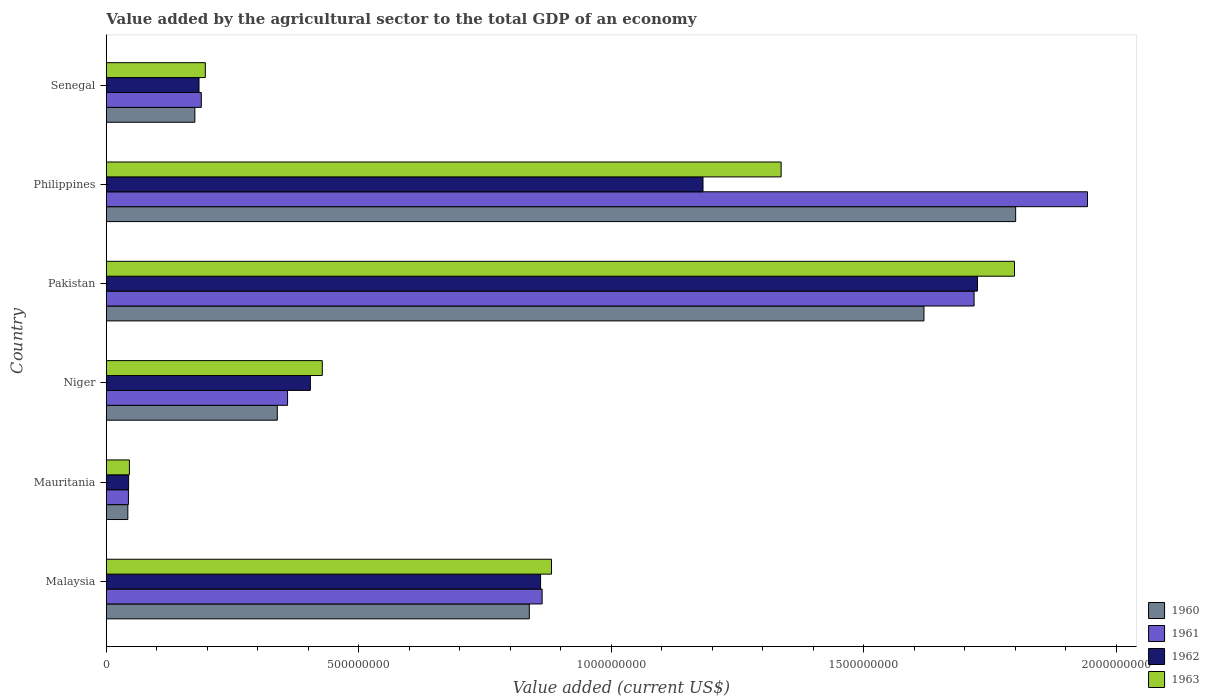How many groups of bars are there?
Keep it short and to the point. 6. Are the number of bars per tick equal to the number of legend labels?
Provide a succinct answer. Yes. How many bars are there on the 1st tick from the top?
Your answer should be very brief. 4. What is the label of the 4th group of bars from the top?
Keep it short and to the point. Niger. What is the value added by the agricultural sector to the total GDP in 1961 in Malaysia?
Provide a succinct answer. 8.63e+08. Across all countries, what is the maximum value added by the agricultural sector to the total GDP in 1962?
Provide a short and direct response. 1.73e+09. Across all countries, what is the minimum value added by the agricultural sector to the total GDP in 1960?
Give a very brief answer. 4.26e+07. In which country was the value added by the agricultural sector to the total GDP in 1963 maximum?
Ensure brevity in your answer.  Pakistan. In which country was the value added by the agricultural sector to the total GDP in 1961 minimum?
Your response must be concise. Mauritania. What is the total value added by the agricultural sector to the total GDP in 1961 in the graph?
Make the answer very short. 5.12e+09. What is the difference between the value added by the agricultural sector to the total GDP in 1960 in Pakistan and that in Senegal?
Keep it short and to the point. 1.44e+09. What is the difference between the value added by the agricultural sector to the total GDP in 1961 in Niger and the value added by the agricultural sector to the total GDP in 1962 in Philippines?
Provide a short and direct response. -8.23e+08. What is the average value added by the agricultural sector to the total GDP in 1963 per country?
Offer a very short reply. 7.81e+08. What is the difference between the value added by the agricultural sector to the total GDP in 1960 and value added by the agricultural sector to the total GDP in 1963 in Philippines?
Provide a short and direct response. 4.64e+08. What is the ratio of the value added by the agricultural sector to the total GDP in 1960 in Philippines to that in Senegal?
Give a very brief answer. 10.27. Is the value added by the agricultural sector to the total GDP in 1961 in Malaysia less than that in Senegal?
Your response must be concise. No. Is the difference between the value added by the agricultural sector to the total GDP in 1960 in Malaysia and Senegal greater than the difference between the value added by the agricultural sector to the total GDP in 1963 in Malaysia and Senegal?
Give a very brief answer. No. What is the difference between the highest and the second highest value added by the agricultural sector to the total GDP in 1960?
Your answer should be compact. 1.82e+08. What is the difference between the highest and the lowest value added by the agricultural sector to the total GDP in 1961?
Your answer should be compact. 1.90e+09. In how many countries, is the value added by the agricultural sector to the total GDP in 1961 greater than the average value added by the agricultural sector to the total GDP in 1961 taken over all countries?
Your answer should be very brief. 3. Is the sum of the value added by the agricultural sector to the total GDP in 1962 in Pakistan and Senegal greater than the maximum value added by the agricultural sector to the total GDP in 1963 across all countries?
Make the answer very short. Yes. Is it the case that in every country, the sum of the value added by the agricultural sector to the total GDP in 1962 and value added by the agricultural sector to the total GDP in 1961 is greater than the sum of value added by the agricultural sector to the total GDP in 1963 and value added by the agricultural sector to the total GDP in 1960?
Make the answer very short. No. What does the 1st bar from the top in Malaysia represents?
Give a very brief answer. 1963. What does the 1st bar from the bottom in Niger represents?
Ensure brevity in your answer.  1960. Are all the bars in the graph horizontal?
Offer a terse response. Yes. Are the values on the major ticks of X-axis written in scientific E-notation?
Ensure brevity in your answer.  No. What is the title of the graph?
Provide a succinct answer. Value added by the agricultural sector to the total GDP of an economy. Does "1989" appear as one of the legend labels in the graph?
Provide a short and direct response. No. What is the label or title of the X-axis?
Your answer should be compact. Value added (current US$). What is the label or title of the Y-axis?
Provide a short and direct response. Country. What is the Value added (current US$) in 1960 in Malaysia?
Provide a succinct answer. 8.38e+08. What is the Value added (current US$) in 1961 in Malaysia?
Keep it short and to the point. 8.63e+08. What is the Value added (current US$) of 1962 in Malaysia?
Offer a terse response. 8.60e+08. What is the Value added (current US$) of 1963 in Malaysia?
Your answer should be very brief. 8.82e+08. What is the Value added (current US$) of 1960 in Mauritania?
Your answer should be compact. 4.26e+07. What is the Value added (current US$) of 1961 in Mauritania?
Offer a terse response. 4.37e+07. What is the Value added (current US$) of 1962 in Mauritania?
Your answer should be very brief. 4.41e+07. What is the Value added (current US$) in 1963 in Mauritania?
Your answer should be compact. 4.57e+07. What is the Value added (current US$) of 1960 in Niger?
Offer a terse response. 3.39e+08. What is the Value added (current US$) in 1961 in Niger?
Offer a very short reply. 3.59e+08. What is the Value added (current US$) of 1962 in Niger?
Make the answer very short. 4.04e+08. What is the Value added (current US$) in 1963 in Niger?
Your answer should be very brief. 4.28e+08. What is the Value added (current US$) of 1960 in Pakistan?
Ensure brevity in your answer.  1.62e+09. What is the Value added (current US$) of 1961 in Pakistan?
Offer a terse response. 1.72e+09. What is the Value added (current US$) in 1962 in Pakistan?
Ensure brevity in your answer.  1.73e+09. What is the Value added (current US$) in 1963 in Pakistan?
Ensure brevity in your answer.  1.80e+09. What is the Value added (current US$) in 1960 in Philippines?
Provide a short and direct response. 1.80e+09. What is the Value added (current US$) in 1961 in Philippines?
Keep it short and to the point. 1.94e+09. What is the Value added (current US$) in 1962 in Philippines?
Ensure brevity in your answer.  1.18e+09. What is the Value added (current US$) of 1963 in Philippines?
Keep it short and to the point. 1.34e+09. What is the Value added (current US$) of 1960 in Senegal?
Your answer should be compact. 1.75e+08. What is the Value added (current US$) of 1961 in Senegal?
Provide a succinct answer. 1.88e+08. What is the Value added (current US$) of 1962 in Senegal?
Provide a short and direct response. 1.84e+08. What is the Value added (current US$) in 1963 in Senegal?
Your answer should be very brief. 1.96e+08. Across all countries, what is the maximum Value added (current US$) in 1960?
Provide a succinct answer. 1.80e+09. Across all countries, what is the maximum Value added (current US$) in 1961?
Offer a terse response. 1.94e+09. Across all countries, what is the maximum Value added (current US$) in 1962?
Provide a short and direct response. 1.73e+09. Across all countries, what is the maximum Value added (current US$) of 1963?
Ensure brevity in your answer.  1.80e+09. Across all countries, what is the minimum Value added (current US$) of 1960?
Your answer should be very brief. 4.26e+07. Across all countries, what is the minimum Value added (current US$) in 1961?
Offer a terse response. 4.37e+07. Across all countries, what is the minimum Value added (current US$) in 1962?
Make the answer very short. 4.41e+07. Across all countries, what is the minimum Value added (current US$) of 1963?
Offer a very short reply. 4.57e+07. What is the total Value added (current US$) in 1960 in the graph?
Your response must be concise. 4.81e+09. What is the total Value added (current US$) in 1961 in the graph?
Your answer should be very brief. 5.12e+09. What is the total Value added (current US$) in 1962 in the graph?
Your answer should be compact. 4.40e+09. What is the total Value added (current US$) in 1963 in the graph?
Offer a terse response. 4.69e+09. What is the difference between the Value added (current US$) of 1960 in Malaysia and that in Mauritania?
Make the answer very short. 7.95e+08. What is the difference between the Value added (current US$) in 1961 in Malaysia and that in Mauritania?
Make the answer very short. 8.19e+08. What is the difference between the Value added (current US$) of 1962 in Malaysia and that in Mauritania?
Make the answer very short. 8.16e+08. What is the difference between the Value added (current US$) in 1963 in Malaysia and that in Mauritania?
Offer a terse response. 8.36e+08. What is the difference between the Value added (current US$) in 1960 in Malaysia and that in Niger?
Offer a terse response. 4.99e+08. What is the difference between the Value added (current US$) in 1961 in Malaysia and that in Niger?
Give a very brief answer. 5.04e+08. What is the difference between the Value added (current US$) in 1962 in Malaysia and that in Niger?
Give a very brief answer. 4.56e+08. What is the difference between the Value added (current US$) of 1963 in Malaysia and that in Niger?
Your answer should be very brief. 4.54e+08. What is the difference between the Value added (current US$) of 1960 in Malaysia and that in Pakistan?
Your response must be concise. -7.82e+08. What is the difference between the Value added (current US$) in 1961 in Malaysia and that in Pakistan?
Offer a very short reply. -8.56e+08. What is the difference between the Value added (current US$) in 1962 in Malaysia and that in Pakistan?
Your response must be concise. -8.65e+08. What is the difference between the Value added (current US$) in 1963 in Malaysia and that in Pakistan?
Offer a terse response. -9.17e+08. What is the difference between the Value added (current US$) of 1960 in Malaysia and that in Philippines?
Keep it short and to the point. -9.63e+08. What is the difference between the Value added (current US$) in 1961 in Malaysia and that in Philippines?
Your response must be concise. -1.08e+09. What is the difference between the Value added (current US$) of 1962 in Malaysia and that in Philippines?
Your response must be concise. -3.22e+08. What is the difference between the Value added (current US$) in 1963 in Malaysia and that in Philippines?
Your answer should be very brief. -4.55e+08. What is the difference between the Value added (current US$) in 1960 in Malaysia and that in Senegal?
Your response must be concise. 6.62e+08. What is the difference between the Value added (current US$) in 1961 in Malaysia and that in Senegal?
Offer a terse response. 6.75e+08. What is the difference between the Value added (current US$) of 1962 in Malaysia and that in Senegal?
Offer a very short reply. 6.76e+08. What is the difference between the Value added (current US$) of 1963 in Malaysia and that in Senegal?
Your answer should be compact. 6.86e+08. What is the difference between the Value added (current US$) in 1960 in Mauritania and that in Niger?
Provide a succinct answer. -2.96e+08. What is the difference between the Value added (current US$) of 1961 in Mauritania and that in Niger?
Provide a succinct answer. -3.15e+08. What is the difference between the Value added (current US$) in 1962 in Mauritania and that in Niger?
Offer a terse response. -3.60e+08. What is the difference between the Value added (current US$) in 1963 in Mauritania and that in Niger?
Ensure brevity in your answer.  -3.82e+08. What is the difference between the Value added (current US$) of 1960 in Mauritania and that in Pakistan?
Ensure brevity in your answer.  -1.58e+09. What is the difference between the Value added (current US$) of 1961 in Mauritania and that in Pakistan?
Your response must be concise. -1.67e+09. What is the difference between the Value added (current US$) of 1962 in Mauritania and that in Pakistan?
Give a very brief answer. -1.68e+09. What is the difference between the Value added (current US$) in 1963 in Mauritania and that in Pakistan?
Your response must be concise. -1.75e+09. What is the difference between the Value added (current US$) of 1960 in Mauritania and that in Philippines?
Your answer should be very brief. -1.76e+09. What is the difference between the Value added (current US$) of 1961 in Mauritania and that in Philippines?
Ensure brevity in your answer.  -1.90e+09. What is the difference between the Value added (current US$) in 1962 in Mauritania and that in Philippines?
Keep it short and to the point. -1.14e+09. What is the difference between the Value added (current US$) in 1963 in Mauritania and that in Philippines?
Offer a very short reply. -1.29e+09. What is the difference between the Value added (current US$) of 1960 in Mauritania and that in Senegal?
Provide a succinct answer. -1.33e+08. What is the difference between the Value added (current US$) in 1961 in Mauritania and that in Senegal?
Offer a terse response. -1.44e+08. What is the difference between the Value added (current US$) in 1962 in Mauritania and that in Senegal?
Your response must be concise. -1.39e+08. What is the difference between the Value added (current US$) in 1963 in Mauritania and that in Senegal?
Your answer should be very brief. -1.50e+08. What is the difference between the Value added (current US$) in 1960 in Niger and that in Pakistan?
Give a very brief answer. -1.28e+09. What is the difference between the Value added (current US$) in 1961 in Niger and that in Pakistan?
Provide a short and direct response. -1.36e+09. What is the difference between the Value added (current US$) in 1962 in Niger and that in Pakistan?
Provide a succinct answer. -1.32e+09. What is the difference between the Value added (current US$) in 1963 in Niger and that in Pakistan?
Keep it short and to the point. -1.37e+09. What is the difference between the Value added (current US$) of 1960 in Niger and that in Philippines?
Provide a short and direct response. -1.46e+09. What is the difference between the Value added (current US$) of 1961 in Niger and that in Philippines?
Offer a very short reply. -1.58e+09. What is the difference between the Value added (current US$) in 1962 in Niger and that in Philippines?
Make the answer very short. -7.78e+08. What is the difference between the Value added (current US$) of 1963 in Niger and that in Philippines?
Provide a succinct answer. -9.09e+08. What is the difference between the Value added (current US$) in 1960 in Niger and that in Senegal?
Your response must be concise. 1.63e+08. What is the difference between the Value added (current US$) of 1961 in Niger and that in Senegal?
Your answer should be very brief. 1.71e+08. What is the difference between the Value added (current US$) of 1962 in Niger and that in Senegal?
Your answer should be compact. 2.21e+08. What is the difference between the Value added (current US$) of 1963 in Niger and that in Senegal?
Your response must be concise. 2.32e+08. What is the difference between the Value added (current US$) in 1960 in Pakistan and that in Philippines?
Provide a succinct answer. -1.82e+08. What is the difference between the Value added (current US$) in 1961 in Pakistan and that in Philippines?
Give a very brief answer. -2.25e+08. What is the difference between the Value added (current US$) in 1962 in Pakistan and that in Philippines?
Provide a succinct answer. 5.44e+08. What is the difference between the Value added (current US$) of 1963 in Pakistan and that in Philippines?
Provide a succinct answer. 4.62e+08. What is the difference between the Value added (current US$) of 1960 in Pakistan and that in Senegal?
Offer a very short reply. 1.44e+09. What is the difference between the Value added (current US$) of 1961 in Pakistan and that in Senegal?
Offer a very short reply. 1.53e+09. What is the difference between the Value added (current US$) of 1962 in Pakistan and that in Senegal?
Give a very brief answer. 1.54e+09. What is the difference between the Value added (current US$) in 1963 in Pakistan and that in Senegal?
Your answer should be compact. 1.60e+09. What is the difference between the Value added (current US$) in 1960 in Philippines and that in Senegal?
Ensure brevity in your answer.  1.63e+09. What is the difference between the Value added (current US$) in 1961 in Philippines and that in Senegal?
Your response must be concise. 1.76e+09. What is the difference between the Value added (current US$) in 1962 in Philippines and that in Senegal?
Your answer should be very brief. 9.98e+08. What is the difference between the Value added (current US$) of 1963 in Philippines and that in Senegal?
Ensure brevity in your answer.  1.14e+09. What is the difference between the Value added (current US$) of 1960 in Malaysia and the Value added (current US$) of 1961 in Mauritania?
Offer a terse response. 7.94e+08. What is the difference between the Value added (current US$) in 1960 in Malaysia and the Value added (current US$) in 1962 in Mauritania?
Your answer should be compact. 7.94e+08. What is the difference between the Value added (current US$) in 1960 in Malaysia and the Value added (current US$) in 1963 in Mauritania?
Give a very brief answer. 7.92e+08. What is the difference between the Value added (current US$) of 1961 in Malaysia and the Value added (current US$) of 1962 in Mauritania?
Offer a terse response. 8.19e+08. What is the difference between the Value added (current US$) of 1961 in Malaysia and the Value added (current US$) of 1963 in Mauritania?
Keep it short and to the point. 8.17e+08. What is the difference between the Value added (current US$) of 1962 in Malaysia and the Value added (current US$) of 1963 in Mauritania?
Ensure brevity in your answer.  8.14e+08. What is the difference between the Value added (current US$) in 1960 in Malaysia and the Value added (current US$) in 1961 in Niger?
Ensure brevity in your answer.  4.79e+08. What is the difference between the Value added (current US$) in 1960 in Malaysia and the Value added (current US$) in 1962 in Niger?
Offer a very short reply. 4.34e+08. What is the difference between the Value added (current US$) in 1960 in Malaysia and the Value added (current US$) in 1963 in Niger?
Offer a very short reply. 4.10e+08. What is the difference between the Value added (current US$) in 1961 in Malaysia and the Value added (current US$) in 1962 in Niger?
Keep it short and to the point. 4.59e+08. What is the difference between the Value added (current US$) in 1961 in Malaysia and the Value added (current US$) in 1963 in Niger?
Offer a very short reply. 4.35e+08. What is the difference between the Value added (current US$) in 1962 in Malaysia and the Value added (current US$) in 1963 in Niger?
Provide a succinct answer. 4.32e+08. What is the difference between the Value added (current US$) of 1960 in Malaysia and the Value added (current US$) of 1961 in Pakistan?
Make the answer very short. -8.81e+08. What is the difference between the Value added (current US$) in 1960 in Malaysia and the Value added (current US$) in 1962 in Pakistan?
Your answer should be very brief. -8.88e+08. What is the difference between the Value added (current US$) in 1960 in Malaysia and the Value added (current US$) in 1963 in Pakistan?
Your answer should be very brief. -9.61e+08. What is the difference between the Value added (current US$) in 1961 in Malaysia and the Value added (current US$) in 1962 in Pakistan?
Your response must be concise. -8.62e+08. What is the difference between the Value added (current US$) in 1961 in Malaysia and the Value added (current US$) in 1963 in Pakistan?
Your response must be concise. -9.36e+08. What is the difference between the Value added (current US$) in 1962 in Malaysia and the Value added (current US$) in 1963 in Pakistan?
Give a very brief answer. -9.39e+08. What is the difference between the Value added (current US$) in 1960 in Malaysia and the Value added (current US$) in 1961 in Philippines?
Offer a terse response. -1.11e+09. What is the difference between the Value added (current US$) of 1960 in Malaysia and the Value added (current US$) of 1962 in Philippines?
Your answer should be compact. -3.44e+08. What is the difference between the Value added (current US$) of 1960 in Malaysia and the Value added (current US$) of 1963 in Philippines?
Your response must be concise. -4.99e+08. What is the difference between the Value added (current US$) in 1961 in Malaysia and the Value added (current US$) in 1962 in Philippines?
Your answer should be very brief. -3.19e+08. What is the difference between the Value added (current US$) of 1961 in Malaysia and the Value added (current US$) of 1963 in Philippines?
Provide a short and direct response. -4.73e+08. What is the difference between the Value added (current US$) of 1962 in Malaysia and the Value added (current US$) of 1963 in Philippines?
Offer a very short reply. -4.76e+08. What is the difference between the Value added (current US$) of 1960 in Malaysia and the Value added (current US$) of 1961 in Senegal?
Your answer should be very brief. 6.50e+08. What is the difference between the Value added (current US$) of 1960 in Malaysia and the Value added (current US$) of 1962 in Senegal?
Provide a short and direct response. 6.54e+08. What is the difference between the Value added (current US$) of 1960 in Malaysia and the Value added (current US$) of 1963 in Senegal?
Provide a short and direct response. 6.42e+08. What is the difference between the Value added (current US$) of 1961 in Malaysia and the Value added (current US$) of 1962 in Senegal?
Keep it short and to the point. 6.80e+08. What is the difference between the Value added (current US$) of 1961 in Malaysia and the Value added (current US$) of 1963 in Senegal?
Offer a very short reply. 6.67e+08. What is the difference between the Value added (current US$) in 1962 in Malaysia and the Value added (current US$) in 1963 in Senegal?
Ensure brevity in your answer.  6.64e+08. What is the difference between the Value added (current US$) in 1960 in Mauritania and the Value added (current US$) in 1961 in Niger?
Offer a very short reply. -3.16e+08. What is the difference between the Value added (current US$) in 1960 in Mauritania and the Value added (current US$) in 1962 in Niger?
Provide a short and direct response. -3.62e+08. What is the difference between the Value added (current US$) in 1960 in Mauritania and the Value added (current US$) in 1963 in Niger?
Make the answer very short. -3.85e+08. What is the difference between the Value added (current US$) in 1961 in Mauritania and the Value added (current US$) in 1962 in Niger?
Your response must be concise. -3.60e+08. What is the difference between the Value added (current US$) of 1961 in Mauritania and the Value added (current US$) of 1963 in Niger?
Your response must be concise. -3.84e+08. What is the difference between the Value added (current US$) in 1962 in Mauritania and the Value added (current US$) in 1963 in Niger?
Give a very brief answer. -3.84e+08. What is the difference between the Value added (current US$) in 1960 in Mauritania and the Value added (current US$) in 1961 in Pakistan?
Provide a succinct answer. -1.68e+09. What is the difference between the Value added (current US$) of 1960 in Mauritania and the Value added (current US$) of 1962 in Pakistan?
Provide a succinct answer. -1.68e+09. What is the difference between the Value added (current US$) of 1960 in Mauritania and the Value added (current US$) of 1963 in Pakistan?
Your answer should be very brief. -1.76e+09. What is the difference between the Value added (current US$) in 1961 in Mauritania and the Value added (current US$) in 1962 in Pakistan?
Provide a short and direct response. -1.68e+09. What is the difference between the Value added (current US$) in 1961 in Mauritania and the Value added (current US$) in 1963 in Pakistan?
Provide a succinct answer. -1.75e+09. What is the difference between the Value added (current US$) in 1962 in Mauritania and the Value added (current US$) in 1963 in Pakistan?
Give a very brief answer. -1.75e+09. What is the difference between the Value added (current US$) of 1960 in Mauritania and the Value added (current US$) of 1961 in Philippines?
Offer a terse response. -1.90e+09. What is the difference between the Value added (current US$) in 1960 in Mauritania and the Value added (current US$) in 1962 in Philippines?
Your answer should be compact. -1.14e+09. What is the difference between the Value added (current US$) of 1960 in Mauritania and the Value added (current US$) of 1963 in Philippines?
Make the answer very short. -1.29e+09. What is the difference between the Value added (current US$) in 1961 in Mauritania and the Value added (current US$) in 1962 in Philippines?
Offer a very short reply. -1.14e+09. What is the difference between the Value added (current US$) in 1961 in Mauritania and the Value added (current US$) in 1963 in Philippines?
Keep it short and to the point. -1.29e+09. What is the difference between the Value added (current US$) in 1962 in Mauritania and the Value added (current US$) in 1963 in Philippines?
Keep it short and to the point. -1.29e+09. What is the difference between the Value added (current US$) of 1960 in Mauritania and the Value added (current US$) of 1961 in Senegal?
Your answer should be very brief. -1.46e+08. What is the difference between the Value added (current US$) of 1960 in Mauritania and the Value added (current US$) of 1962 in Senegal?
Make the answer very short. -1.41e+08. What is the difference between the Value added (current US$) of 1960 in Mauritania and the Value added (current US$) of 1963 in Senegal?
Your response must be concise. -1.53e+08. What is the difference between the Value added (current US$) of 1961 in Mauritania and the Value added (current US$) of 1962 in Senegal?
Provide a succinct answer. -1.40e+08. What is the difference between the Value added (current US$) in 1961 in Mauritania and the Value added (current US$) in 1963 in Senegal?
Your response must be concise. -1.52e+08. What is the difference between the Value added (current US$) of 1962 in Mauritania and the Value added (current US$) of 1963 in Senegal?
Your answer should be very brief. -1.52e+08. What is the difference between the Value added (current US$) in 1960 in Niger and the Value added (current US$) in 1961 in Pakistan?
Keep it short and to the point. -1.38e+09. What is the difference between the Value added (current US$) of 1960 in Niger and the Value added (current US$) of 1962 in Pakistan?
Keep it short and to the point. -1.39e+09. What is the difference between the Value added (current US$) of 1960 in Niger and the Value added (current US$) of 1963 in Pakistan?
Your answer should be very brief. -1.46e+09. What is the difference between the Value added (current US$) in 1961 in Niger and the Value added (current US$) in 1962 in Pakistan?
Your response must be concise. -1.37e+09. What is the difference between the Value added (current US$) of 1961 in Niger and the Value added (current US$) of 1963 in Pakistan?
Offer a very short reply. -1.44e+09. What is the difference between the Value added (current US$) of 1962 in Niger and the Value added (current US$) of 1963 in Pakistan?
Offer a terse response. -1.39e+09. What is the difference between the Value added (current US$) in 1960 in Niger and the Value added (current US$) in 1961 in Philippines?
Your answer should be very brief. -1.60e+09. What is the difference between the Value added (current US$) in 1960 in Niger and the Value added (current US$) in 1962 in Philippines?
Your answer should be compact. -8.43e+08. What is the difference between the Value added (current US$) in 1960 in Niger and the Value added (current US$) in 1963 in Philippines?
Ensure brevity in your answer.  -9.98e+08. What is the difference between the Value added (current US$) in 1961 in Niger and the Value added (current US$) in 1962 in Philippines?
Give a very brief answer. -8.23e+08. What is the difference between the Value added (current US$) of 1961 in Niger and the Value added (current US$) of 1963 in Philippines?
Your answer should be compact. -9.77e+08. What is the difference between the Value added (current US$) of 1962 in Niger and the Value added (current US$) of 1963 in Philippines?
Provide a short and direct response. -9.32e+08. What is the difference between the Value added (current US$) in 1960 in Niger and the Value added (current US$) in 1961 in Senegal?
Offer a very short reply. 1.50e+08. What is the difference between the Value added (current US$) of 1960 in Niger and the Value added (current US$) of 1962 in Senegal?
Your answer should be very brief. 1.55e+08. What is the difference between the Value added (current US$) of 1960 in Niger and the Value added (current US$) of 1963 in Senegal?
Your answer should be compact. 1.43e+08. What is the difference between the Value added (current US$) in 1961 in Niger and the Value added (current US$) in 1962 in Senegal?
Your response must be concise. 1.75e+08. What is the difference between the Value added (current US$) of 1961 in Niger and the Value added (current US$) of 1963 in Senegal?
Ensure brevity in your answer.  1.63e+08. What is the difference between the Value added (current US$) in 1962 in Niger and the Value added (current US$) in 1963 in Senegal?
Ensure brevity in your answer.  2.08e+08. What is the difference between the Value added (current US$) in 1960 in Pakistan and the Value added (current US$) in 1961 in Philippines?
Your answer should be compact. -3.24e+08. What is the difference between the Value added (current US$) in 1960 in Pakistan and the Value added (current US$) in 1962 in Philippines?
Keep it short and to the point. 4.38e+08. What is the difference between the Value added (current US$) in 1960 in Pakistan and the Value added (current US$) in 1963 in Philippines?
Provide a short and direct response. 2.83e+08. What is the difference between the Value added (current US$) in 1961 in Pakistan and the Value added (current US$) in 1962 in Philippines?
Make the answer very short. 5.37e+08. What is the difference between the Value added (current US$) in 1961 in Pakistan and the Value added (current US$) in 1963 in Philippines?
Your response must be concise. 3.82e+08. What is the difference between the Value added (current US$) in 1962 in Pakistan and the Value added (current US$) in 1963 in Philippines?
Provide a short and direct response. 3.89e+08. What is the difference between the Value added (current US$) of 1960 in Pakistan and the Value added (current US$) of 1961 in Senegal?
Your answer should be very brief. 1.43e+09. What is the difference between the Value added (current US$) of 1960 in Pakistan and the Value added (current US$) of 1962 in Senegal?
Provide a succinct answer. 1.44e+09. What is the difference between the Value added (current US$) in 1960 in Pakistan and the Value added (current US$) in 1963 in Senegal?
Your response must be concise. 1.42e+09. What is the difference between the Value added (current US$) in 1961 in Pakistan and the Value added (current US$) in 1962 in Senegal?
Provide a short and direct response. 1.54e+09. What is the difference between the Value added (current US$) in 1961 in Pakistan and the Value added (current US$) in 1963 in Senegal?
Offer a very short reply. 1.52e+09. What is the difference between the Value added (current US$) in 1962 in Pakistan and the Value added (current US$) in 1963 in Senegal?
Your answer should be compact. 1.53e+09. What is the difference between the Value added (current US$) of 1960 in Philippines and the Value added (current US$) of 1961 in Senegal?
Keep it short and to the point. 1.61e+09. What is the difference between the Value added (current US$) in 1960 in Philippines and the Value added (current US$) in 1962 in Senegal?
Keep it short and to the point. 1.62e+09. What is the difference between the Value added (current US$) of 1960 in Philippines and the Value added (current US$) of 1963 in Senegal?
Offer a terse response. 1.60e+09. What is the difference between the Value added (current US$) in 1961 in Philippines and the Value added (current US$) in 1962 in Senegal?
Give a very brief answer. 1.76e+09. What is the difference between the Value added (current US$) in 1961 in Philippines and the Value added (current US$) in 1963 in Senegal?
Your response must be concise. 1.75e+09. What is the difference between the Value added (current US$) in 1962 in Philippines and the Value added (current US$) in 1963 in Senegal?
Offer a very short reply. 9.86e+08. What is the average Value added (current US$) in 1960 per country?
Offer a terse response. 8.02e+08. What is the average Value added (current US$) of 1961 per country?
Offer a very short reply. 8.53e+08. What is the average Value added (current US$) of 1962 per country?
Your answer should be compact. 7.33e+08. What is the average Value added (current US$) of 1963 per country?
Offer a terse response. 7.81e+08. What is the difference between the Value added (current US$) in 1960 and Value added (current US$) in 1961 in Malaysia?
Your response must be concise. -2.54e+07. What is the difference between the Value added (current US$) of 1960 and Value added (current US$) of 1962 in Malaysia?
Provide a succinct answer. -2.23e+07. What is the difference between the Value added (current US$) in 1960 and Value added (current US$) in 1963 in Malaysia?
Offer a terse response. -4.39e+07. What is the difference between the Value added (current US$) of 1961 and Value added (current US$) of 1962 in Malaysia?
Give a very brief answer. 3.09e+06. What is the difference between the Value added (current US$) of 1961 and Value added (current US$) of 1963 in Malaysia?
Provide a short and direct response. -1.85e+07. What is the difference between the Value added (current US$) in 1962 and Value added (current US$) in 1963 in Malaysia?
Offer a terse response. -2.16e+07. What is the difference between the Value added (current US$) in 1960 and Value added (current US$) in 1961 in Mauritania?
Ensure brevity in your answer.  -1.15e+06. What is the difference between the Value added (current US$) of 1960 and Value added (current US$) of 1962 in Mauritania?
Provide a succinct answer. -1.54e+06. What is the difference between the Value added (current US$) in 1960 and Value added (current US$) in 1963 in Mauritania?
Provide a short and direct response. -3.07e+06. What is the difference between the Value added (current US$) of 1961 and Value added (current US$) of 1962 in Mauritania?
Offer a terse response. -3.84e+05. What is the difference between the Value added (current US$) of 1961 and Value added (current US$) of 1963 in Mauritania?
Offer a terse response. -1.92e+06. What is the difference between the Value added (current US$) in 1962 and Value added (current US$) in 1963 in Mauritania?
Provide a succinct answer. -1.54e+06. What is the difference between the Value added (current US$) of 1960 and Value added (current US$) of 1961 in Niger?
Ensure brevity in your answer.  -2.03e+07. What is the difference between the Value added (current US$) in 1960 and Value added (current US$) in 1962 in Niger?
Your answer should be very brief. -6.55e+07. What is the difference between the Value added (current US$) in 1960 and Value added (current US$) in 1963 in Niger?
Keep it short and to the point. -8.91e+07. What is the difference between the Value added (current US$) in 1961 and Value added (current US$) in 1962 in Niger?
Your answer should be very brief. -4.52e+07. What is the difference between the Value added (current US$) of 1961 and Value added (current US$) of 1963 in Niger?
Keep it short and to the point. -6.88e+07. What is the difference between the Value added (current US$) of 1962 and Value added (current US$) of 1963 in Niger?
Ensure brevity in your answer.  -2.36e+07. What is the difference between the Value added (current US$) in 1960 and Value added (current US$) in 1961 in Pakistan?
Provide a succinct answer. -9.93e+07. What is the difference between the Value added (current US$) in 1960 and Value added (current US$) in 1962 in Pakistan?
Your answer should be compact. -1.06e+08. What is the difference between the Value added (current US$) in 1960 and Value added (current US$) in 1963 in Pakistan?
Your answer should be compact. -1.79e+08. What is the difference between the Value added (current US$) of 1961 and Value added (current US$) of 1962 in Pakistan?
Your answer should be very brief. -6.72e+06. What is the difference between the Value added (current US$) in 1961 and Value added (current US$) in 1963 in Pakistan?
Make the answer very short. -8.00e+07. What is the difference between the Value added (current US$) in 1962 and Value added (current US$) in 1963 in Pakistan?
Offer a terse response. -7.33e+07. What is the difference between the Value added (current US$) in 1960 and Value added (current US$) in 1961 in Philippines?
Make the answer very short. -1.42e+08. What is the difference between the Value added (current US$) in 1960 and Value added (current US$) in 1962 in Philippines?
Ensure brevity in your answer.  6.19e+08. What is the difference between the Value added (current US$) of 1960 and Value added (current US$) of 1963 in Philippines?
Keep it short and to the point. 4.64e+08. What is the difference between the Value added (current US$) of 1961 and Value added (current US$) of 1962 in Philippines?
Your answer should be compact. 7.61e+08. What is the difference between the Value added (current US$) in 1961 and Value added (current US$) in 1963 in Philippines?
Make the answer very short. 6.07e+08. What is the difference between the Value added (current US$) in 1962 and Value added (current US$) in 1963 in Philippines?
Your answer should be compact. -1.55e+08. What is the difference between the Value added (current US$) in 1960 and Value added (current US$) in 1961 in Senegal?
Offer a terse response. -1.28e+07. What is the difference between the Value added (current US$) of 1960 and Value added (current US$) of 1962 in Senegal?
Your answer should be very brief. -8.24e+06. What is the difference between the Value added (current US$) in 1960 and Value added (current US$) in 1963 in Senegal?
Offer a terse response. -2.07e+07. What is the difference between the Value added (current US$) of 1961 and Value added (current US$) of 1962 in Senegal?
Provide a succinct answer. 4.54e+06. What is the difference between the Value added (current US$) of 1961 and Value added (current US$) of 1963 in Senegal?
Your answer should be compact. -7.96e+06. What is the difference between the Value added (current US$) of 1962 and Value added (current US$) of 1963 in Senegal?
Provide a short and direct response. -1.25e+07. What is the ratio of the Value added (current US$) in 1960 in Malaysia to that in Mauritania?
Offer a terse response. 19.67. What is the ratio of the Value added (current US$) in 1961 in Malaysia to that in Mauritania?
Your answer should be compact. 19.73. What is the ratio of the Value added (current US$) of 1962 in Malaysia to that in Mauritania?
Your response must be concise. 19.49. What is the ratio of the Value added (current US$) in 1963 in Malaysia to that in Mauritania?
Your response must be concise. 19.31. What is the ratio of the Value added (current US$) of 1960 in Malaysia to that in Niger?
Your answer should be compact. 2.47. What is the ratio of the Value added (current US$) in 1961 in Malaysia to that in Niger?
Your answer should be compact. 2.4. What is the ratio of the Value added (current US$) of 1962 in Malaysia to that in Niger?
Your response must be concise. 2.13. What is the ratio of the Value added (current US$) of 1963 in Malaysia to that in Niger?
Provide a succinct answer. 2.06. What is the ratio of the Value added (current US$) of 1960 in Malaysia to that in Pakistan?
Offer a very short reply. 0.52. What is the ratio of the Value added (current US$) of 1961 in Malaysia to that in Pakistan?
Offer a terse response. 0.5. What is the ratio of the Value added (current US$) in 1962 in Malaysia to that in Pakistan?
Provide a succinct answer. 0.5. What is the ratio of the Value added (current US$) in 1963 in Malaysia to that in Pakistan?
Keep it short and to the point. 0.49. What is the ratio of the Value added (current US$) of 1960 in Malaysia to that in Philippines?
Offer a terse response. 0.47. What is the ratio of the Value added (current US$) of 1961 in Malaysia to that in Philippines?
Give a very brief answer. 0.44. What is the ratio of the Value added (current US$) in 1962 in Malaysia to that in Philippines?
Your answer should be very brief. 0.73. What is the ratio of the Value added (current US$) of 1963 in Malaysia to that in Philippines?
Offer a terse response. 0.66. What is the ratio of the Value added (current US$) in 1960 in Malaysia to that in Senegal?
Your answer should be compact. 4.78. What is the ratio of the Value added (current US$) of 1961 in Malaysia to that in Senegal?
Keep it short and to the point. 4.59. What is the ratio of the Value added (current US$) in 1962 in Malaysia to that in Senegal?
Your response must be concise. 4.68. What is the ratio of the Value added (current US$) of 1963 in Malaysia to that in Senegal?
Offer a terse response. 4.5. What is the ratio of the Value added (current US$) in 1960 in Mauritania to that in Niger?
Keep it short and to the point. 0.13. What is the ratio of the Value added (current US$) in 1961 in Mauritania to that in Niger?
Offer a terse response. 0.12. What is the ratio of the Value added (current US$) in 1962 in Mauritania to that in Niger?
Your answer should be compact. 0.11. What is the ratio of the Value added (current US$) of 1963 in Mauritania to that in Niger?
Offer a terse response. 0.11. What is the ratio of the Value added (current US$) of 1960 in Mauritania to that in Pakistan?
Your answer should be compact. 0.03. What is the ratio of the Value added (current US$) in 1961 in Mauritania to that in Pakistan?
Make the answer very short. 0.03. What is the ratio of the Value added (current US$) in 1962 in Mauritania to that in Pakistan?
Provide a succinct answer. 0.03. What is the ratio of the Value added (current US$) of 1963 in Mauritania to that in Pakistan?
Your response must be concise. 0.03. What is the ratio of the Value added (current US$) of 1960 in Mauritania to that in Philippines?
Offer a very short reply. 0.02. What is the ratio of the Value added (current US$) in 1961 in Mauritania to that in Philippines?
Offer a terse response. 0.02. What is the ratio of the Value added (current US$) in 1962 in Mauritania to that in Philippines?
Offer a very short reply. 0.04. What is the ratio of the Value added (current US$) in 1963 in Mauritania to that in Philippines?
Keep it short and to the point. 0.03. What is the ratio of the Value added (current US$) in 1960 in Mauritania to that in Senegal?
Your answer should be compact. 0.24. What is the ratio of the Value added (current US$) in 1961 in Mauritania to that in Senegal?
Your answer should be compact. 0.23. What is the ratio of the Value added (current US$) of 1962 in Mauritania to that in Senegal?
Provide a short and direct response. 0.24. What is the ratio of the Value added (current US$) in 1963 in Mauritania to that in Senegal?
Offer a very short reply. 0.23. What is the ratio of the Value added (current US$) in 1960 in Niger to that in Pakistan?
Your answer should be very brief. 0.21. What is the ratio of the Value added (current US$) of 1961 in Niger to that in Pakistan?
Give a very brief answer. 0.21. What is the ratio of the Value added (current US$) of 1962 in Niger to that in Pakistan?
Provide a succinct answer. 0.23. What is the ratio of the Value added (current US$) of 1963 in Niger to that in Pakistan?
Keep it short and to the point. 0.24. What is the ratio of the Value added (current US$) of 1960 in Niger to that in Philippines?
Give a very brief answer. 0.19. What is the ratio of the Value added (current US$) of 1961 in Niger to that in Philippines?
Give a very brief answer. 0.18. What is the ratio of the Value added (current US$) in 1962 in Niger to that in Philippines?
Your answer should be compact. 0.34. What is the ratio of the Value added (current US$) of 1963 in Niger to that in Philippines?
Offer a very short reply. 0.32. What is the ratio of the Value added (current US$) of 1960 in Niger to that in Senegal?
Offer a terse response. 1.93. What is the ratio of the Value added (current US$) in 1961 in Niger to that in Senegal?
Provide a short and direct response. 1.91. What is the ratio of the Value added (current US$) of 1962 in Niger to that in Senegal?
Provide a succinct answer. 2.2. What is the ratio of the Value added (current US$) in 1963 in Niger to that in Senegal?
Give a very brief answer. 2.18. What is the ratio of the Value added (current US$) in 1960 in Pakistan to that in Philippines?
Your response must be concise. 0.9. What is the ratio of the Value added (current US$) in 1961 in Pakistan to that in Philippines?
Offer a terse response. 0.88. What is the ratio of the Value added (current US$) in 1962 in Pakistan to that in Philippines?
Give a very brief answer. 1.46. What is the ratio of the Value added (current US$) in 1963 in Pakistan to that in Philippines?
Ensure brevity in your answer.  1.35. What is the ratio of the Value added (current US$) of 1960 in Pakistan to that in Senegal?
Your answer should be very brief. 9.24. What is the ratio of the Value added (current US$) in 1961 in Pakistan to that in Senegal?
Make the answer very short. 9.14. What is the ratio of the Value added (current US$) of 1962 in Pakistan to that in Senegal?
Your response must be concise. 9.4. What is the ratio of the Value added (current US$) in 1963 in Pakistan to that in Senegal?
Your answer should be very brief. 9.17. What is the ratio of the Value added (current US$) in 1960 in Philippines to that in Senegal?
Make the answer very short. 10.27. What is the ratio of the Value added (current US$) of 1961 in Philippines to that in Senegal?
Offer a very short reply. 10.33. What is the ratio of the Value added (current US$) of 1962 in Philippines to that in Senegal?
Keep it short and to the point. 6.44. What is the ratio of the Value added (current US$) in 1963 in Philippines to that in Senegal?
Your answer should be very brief. 6.82. What is the difference between the highest and the second highest Value added (current US$) in 1960?
Ensure brevity in your answer.  1.82e+08. What is the difference between the highest and the second highest Value added (current US$) in 1961?
Provide a short and direct response. 2.25e+08. What is the difference between the highest and the second highest Value added (current US$) in 1962?
Provide a succinct answer. 5.44e+08. What is the difference between the highest and the second highest Value added (current US$) in 1963?
Ensure brevity in your answer.  4.62e+08. What is the difference between the highest and the lowest Value added (current US$) in 1960?
Keep it short and to the point. 1.76e+09. What is the difference between the highest and the lowest Value added (current US$) of 1961?
Offer a very short reply. 1.90e+09. What is the difference between the highest and the lowest Value added (current US$) of 1962?
Give a very brief answer. 1.68e+09. What is the difference between the highest and the lowest Value added (current US$) of 1963?
Your answer should be very brief. 1.75e+09. 